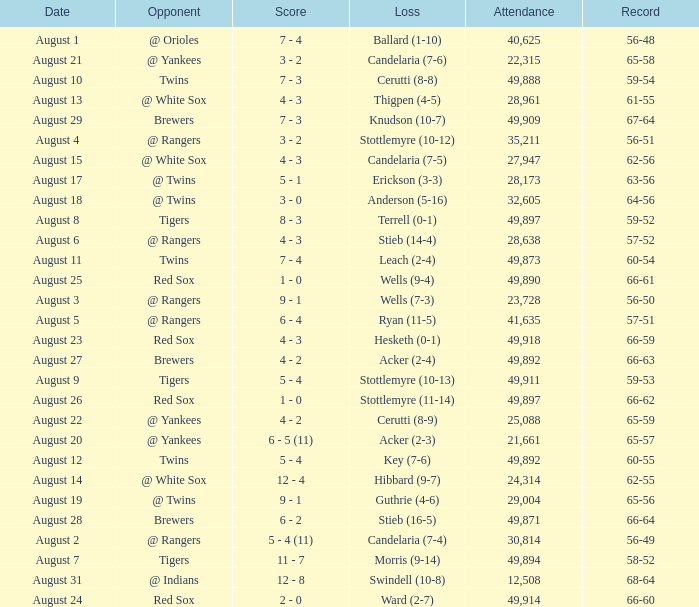What was the record of the game that had a loss of Stottlemyre (10-12)? 56-51. 